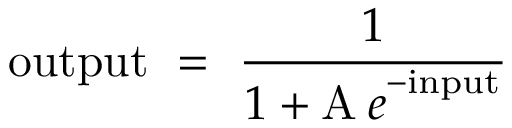<formula> <loc_0><loc_0><loc_500><loc_500>o u t p u t \ = \ { \frac { 1 } { 1 + { \mathrm A \, { e } } ^ { - i n p u t } } }</formula> 